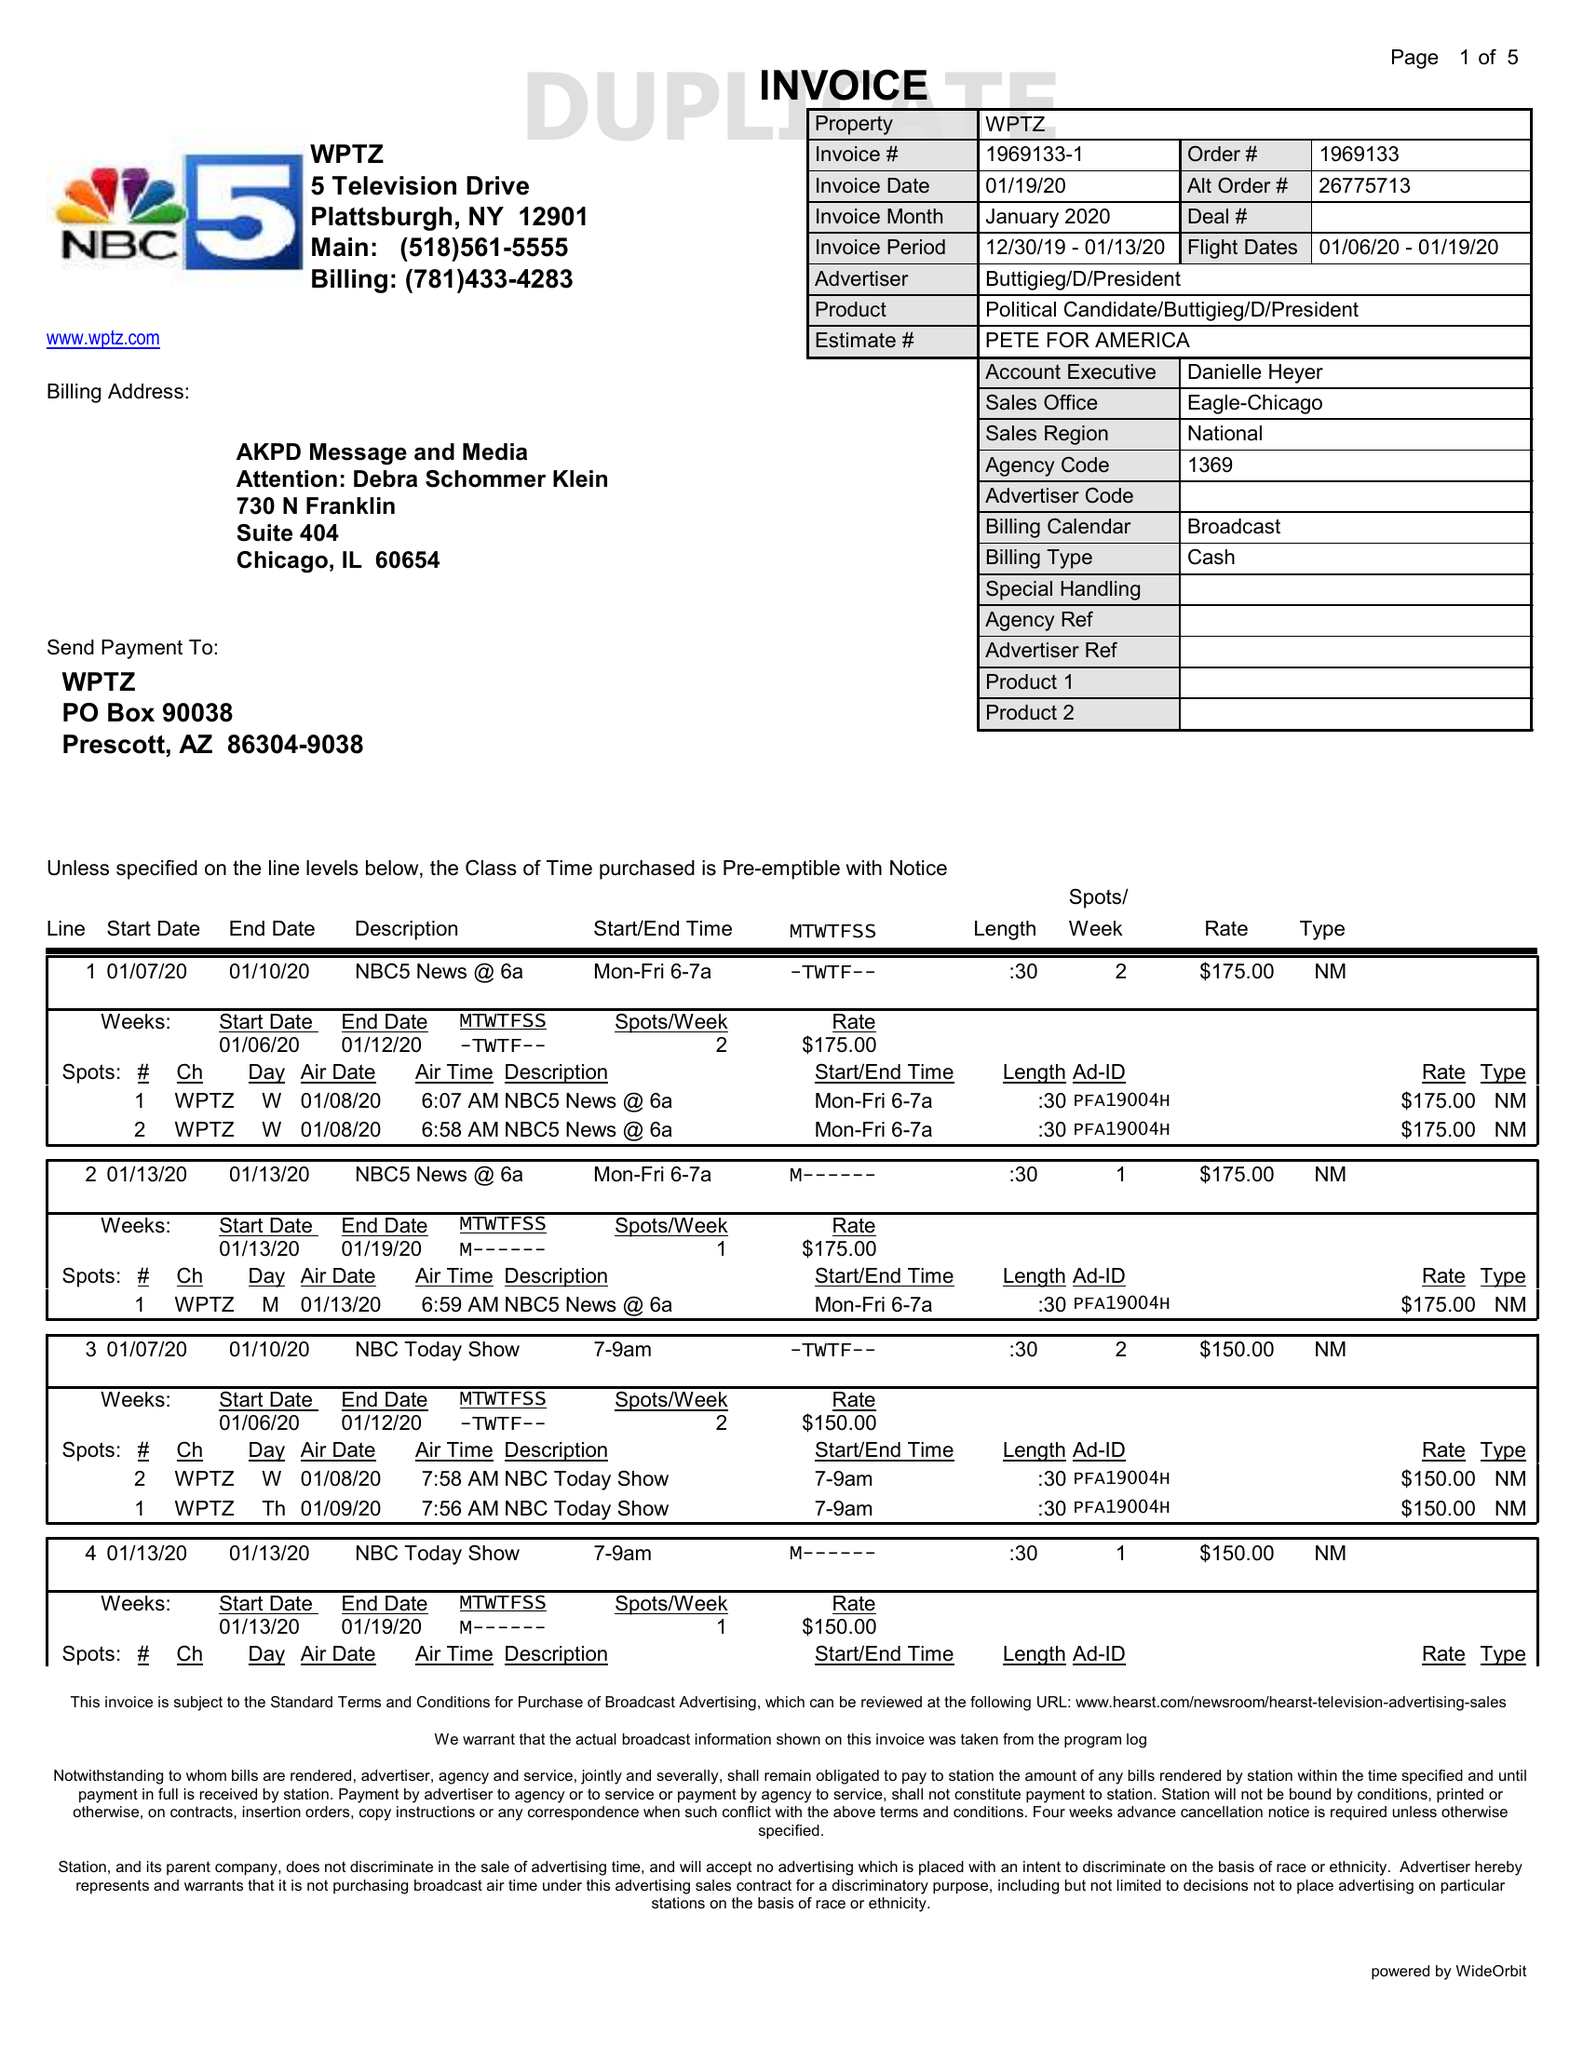What is the value for the flight_from?
Answer the question using a single word or phrase. 01/06/20 